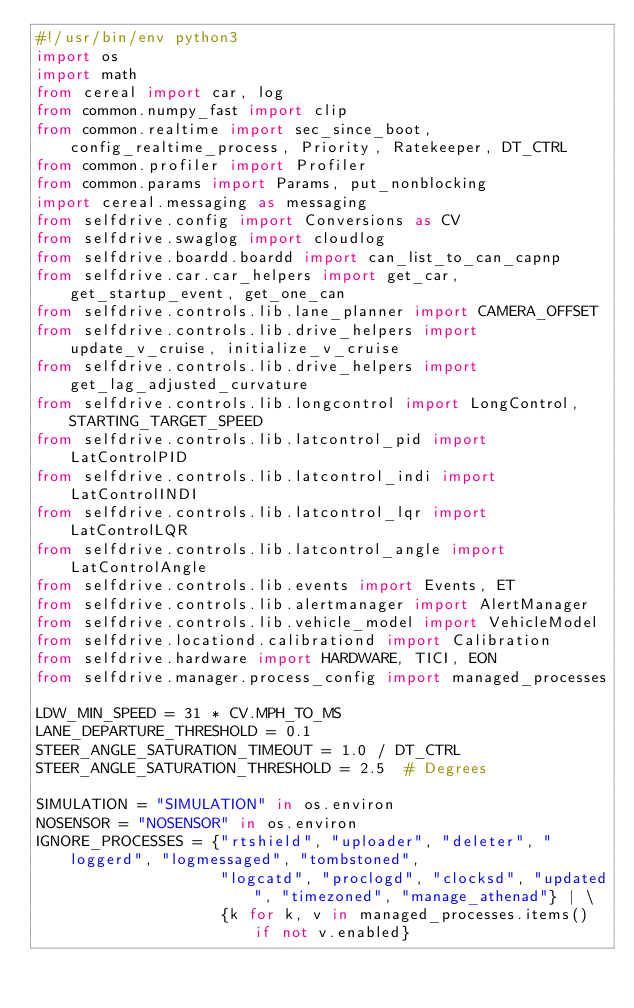<code> <loc_0><loc_0><loc_500><loc_500><_Python_>#!/usr/bin/env python3
import os
import math
from cereal import car, log
from common.numpy_fast import clip
from common.realtime import sec_since_boot, config_realtime_process, Priority, Ratekeeper, DT_CTRL
from common.profiler import Profiler
from common.params import Params, put_nonblocking
import cereal.messaging as messaging
from selfdrive.config import Conversions as CV
from selfdrive.swaglog import cloudlog
from selfdrive.boardd.boardd import can_list_to_can_capnp
from selfdrive.car.car_helpers import get_car, get_startup_event, get_one_can
from selfdrive.controls.lib.lane_planner import CAMERA_OFFSET
from selfdrive.controls.lib.drive_helpers import update_v_cruise, initialize_v_cruise
from selfdrive.controls.lib.drive_helpers import get_lag_adjusted_curvature
from selfdrive.controls.lib.longcontrol import LongControl, STARTING_TARGET_SPEED
from selfdrive.controls.lib.latcontrol_pid import LatControlPID
from selfdrive.controls.lib.latcontrol_indi import LatControlINDI
from selfdrive.controls.lib.latcontrol_lqr import LatControlLQR
from selfdrive.controls.lib.latcontrol_angle import LatControlAngle
from selfdrive.controls.lib.events import Events, ET
from selfdrive.controls.lib.alertmanager import AlertManager
from selfdrive.controls.lib.vehicle_model import VehicleModel
from selfdrive.locationd.calibrationd import Calibration
from selfdrive.hardware import HARDWARE, TICI, EON
from selfdrive.manager.process_config import managed_processes

LDW_MIN_SPEED = 31 * CV.MPH_TO_MS
LANE_DEPARTURE_THRESHOLD = 0.1
STEER_ANGLE_SATURATION_TIMEOUT = 1.0 / DT_CTRL
STEER_ANGLE_SATURATION_THRESHOLD = 2.5  # Degrees

SIMULATION = "SIMULATION" in os.environ
NOSENSOR = "NOSENSOR" in os.environ
IGNORE_PROCESSES = {"rtshield", "uploader", "deleter", "loggerd", "logmessaged", "tombstoned",
                    "logcatd", "proclogd", "clocksd", "updated", "timezoned", "manage_athenad"} | \
                    {k for k, v in managed_processes.items() if not v.enabled}
</code> 